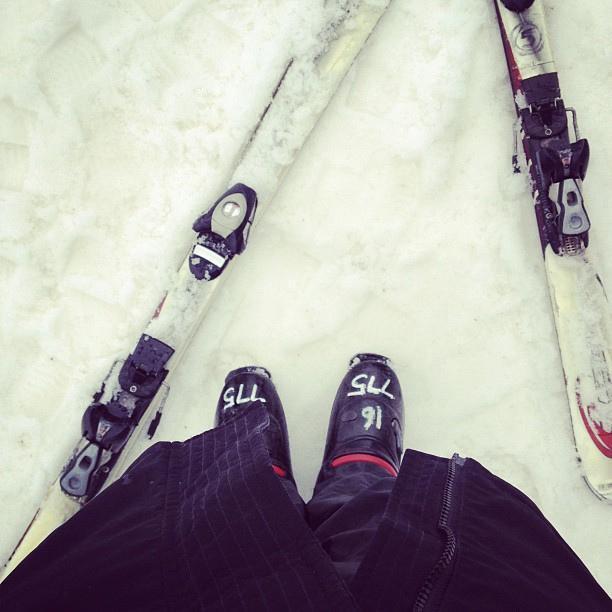How many feet are shown?
Give a very brief answer. 2. How many people can be seen?
Give a very brief answer. 1. 